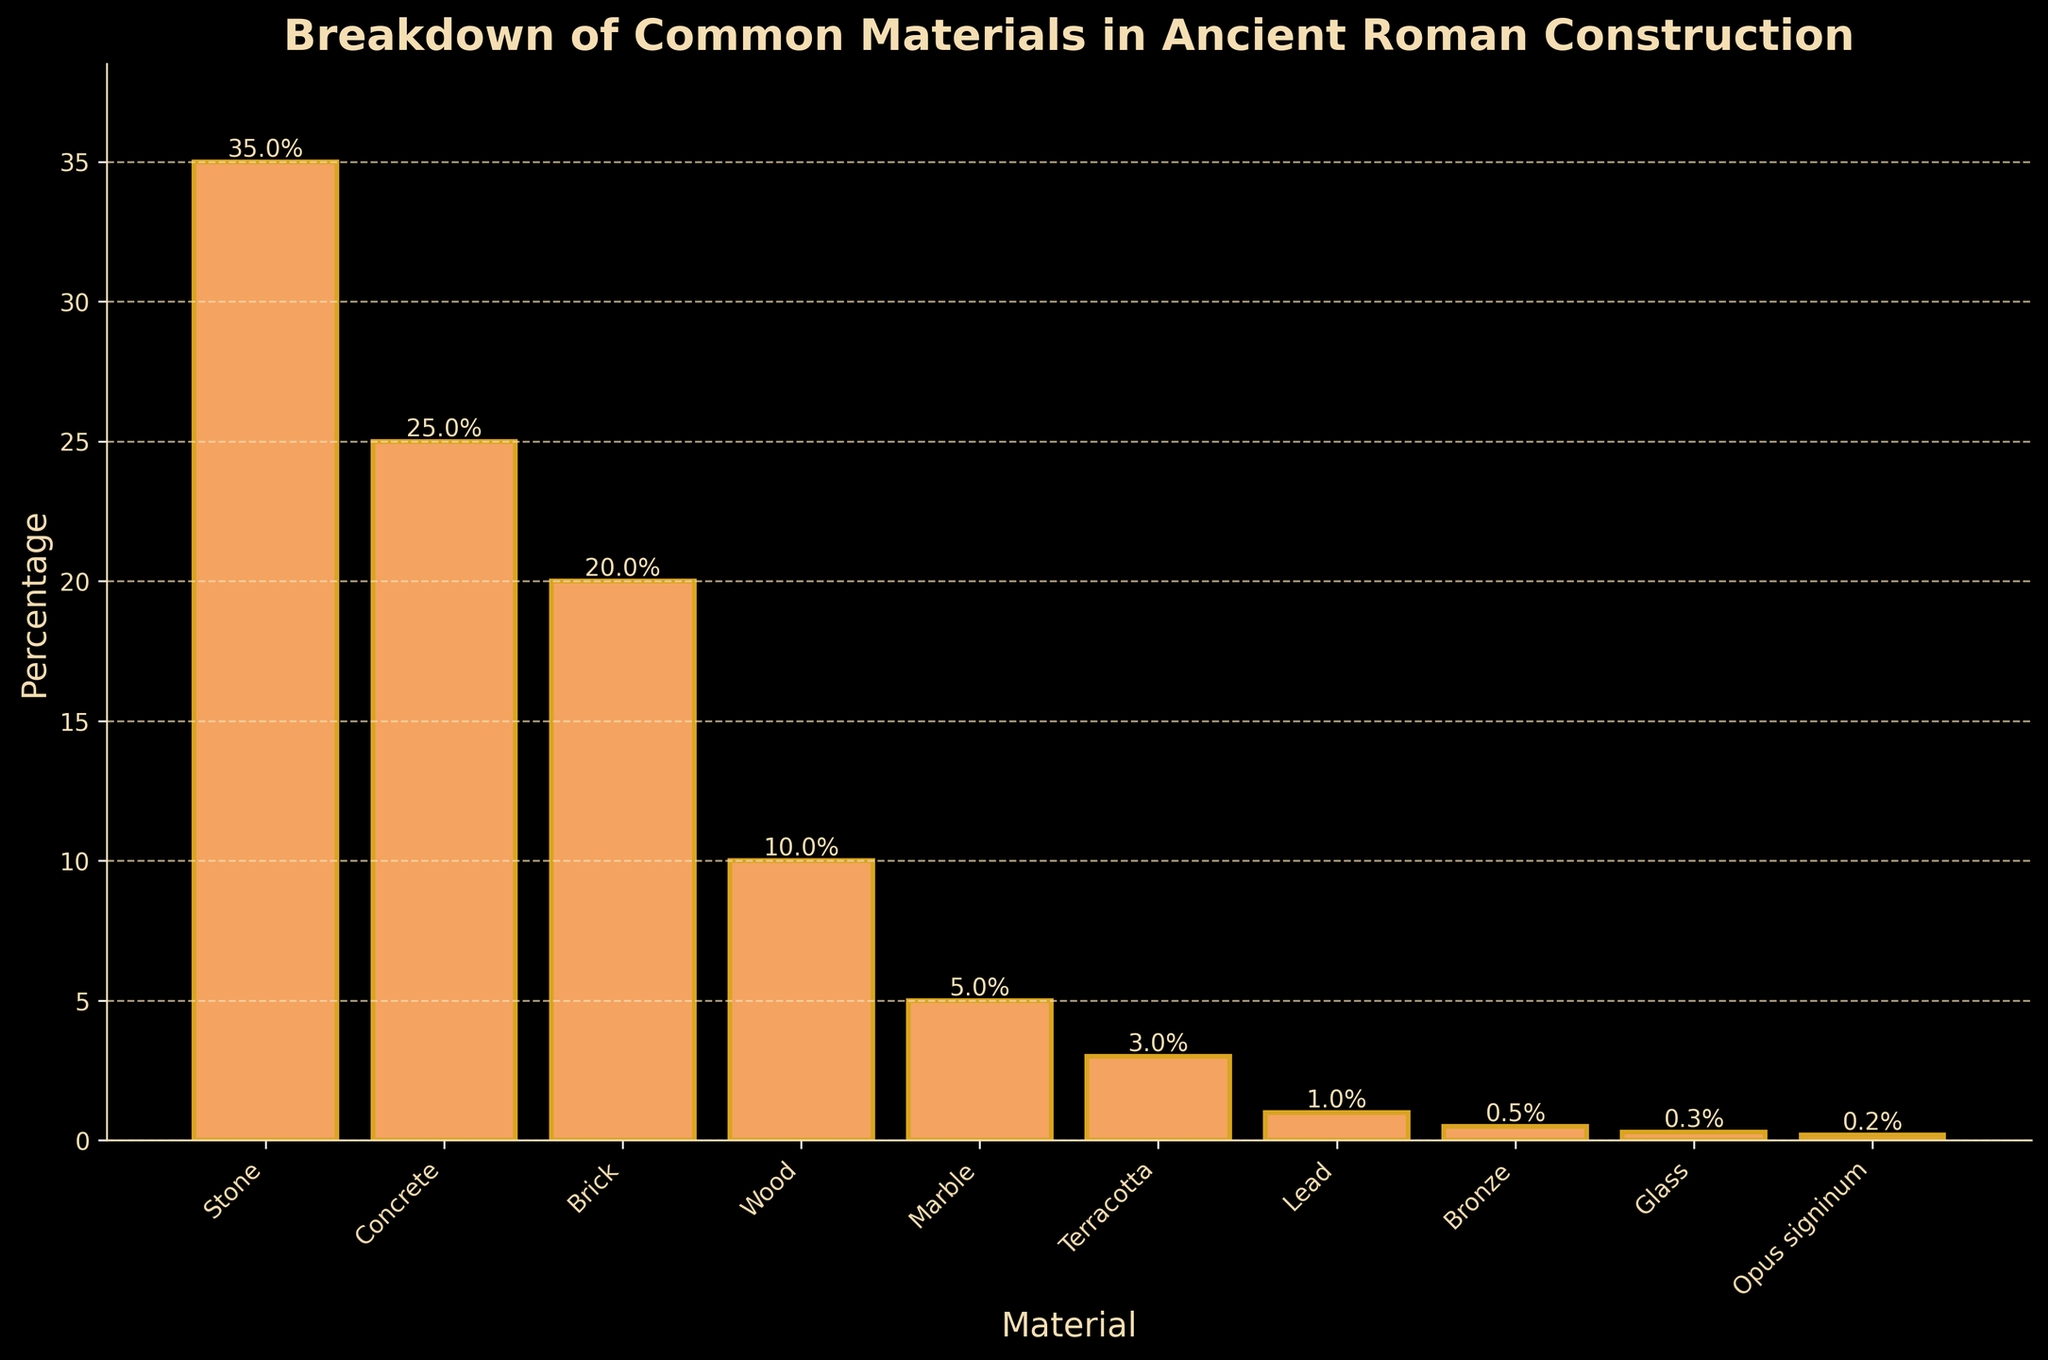Which material is used most commonly in ancient Roman construction? The material with the highest bar in the chart represents the most used material. The size of the bar for Stone is the largest. Thus, Stone is the most commonly used material.
Answer: Stone How much more common is the usage of Stone compared to Concrete? To find the difference, subtract the percentage of Concrete from the percentage of Stone (35% - 25%).
Answer: 10% What is the combined usage percentage of Marble and Terracotta? To find the total, add the percentages of Marble and Terracotta together (5% + 3%).
Answer: 8% Which materials have a usage percentage of less than 1%? Identify the bars with heights less than 1%: Lead, Bronze, Glass, and Opus signinum.
Answer: Lead, Bronze, Glass, Opus signinum Is the usage percentage of Wood greater than or less than the usage percentage of Brick? Compare the heights of the bars for Wood and Brick. Wood has 10% while Brick has 20%.
Answer: Less than What is the average usage percentage of the top three most common materials? Identify the top three materials (Stone, Concrete, Brick) and calculate the average: (35 + 25 + 20) / 3.
Answer: 26.67% By how much does the usage percentage of Marble exceed that of Glass? Subtract the percentage of Glass from the percentage of Marble (5% - 0.3%).
Answer: 4.7% Which material’s bar is the shortest? Observe the bar with the least height representing the lowest percentage. The shortest bar is for Opus signinum.
Answer: Opus signinum What percentage of materials used fall below an 8% usage rate? Identify the materials with usage percentages less than 8% and sum them: Marble (5%), Terracotta (3%), Lead (1%), Bronze (0.5%), Glass (0.3%), Opus signinum (0.2%). Sum = 10%.
Answer: 10% 